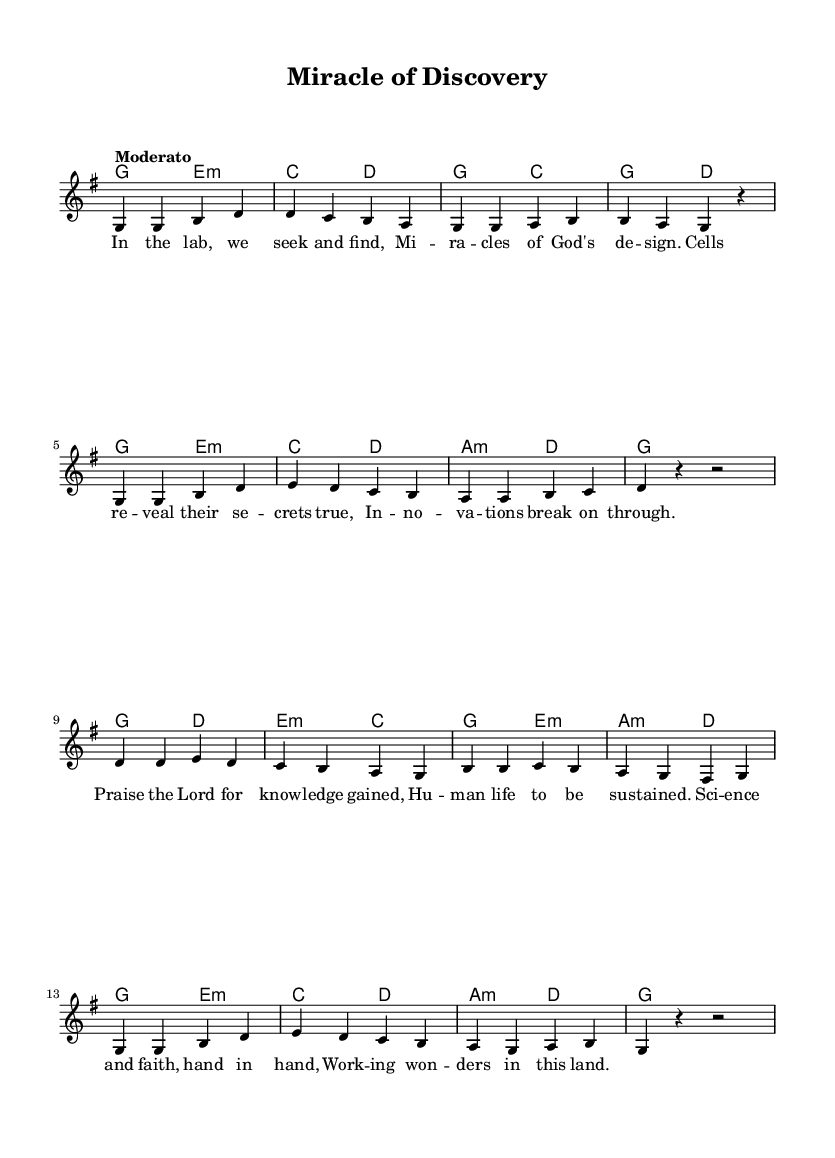What is the key signature of this music? The key signature is indicated at the beginning of the sheet music and shows one sharp (F#), which corresponds to the key of G major.
Answer: G major What is the time signature of this music? The time signature is located at the beginning of the score and shows a 4 over 4, indicating four beats in a measure.
Answer: 4/4 What is the tempo marking for this piece? The tempo marking appears near the beginning of the music and denotes "Moderato," indicating a moderate pace for the performance.
Answer: Moderato How many measures are there in the melody section? By counting the number of vertical lines (bar lines) in the melody, we can determine that there are a total of 16 measures present in the melody.
Answer: 16 What is the first lyric of the song? The lyrics start at the first note of the melody, which is "In the lab," indicating the opening phrase of the song.
Answer: In the lab What type of harmony is used in this piece? The chord symbols located above the staff indicate that basic triads and seventh chords are utilized, which is typical for Gospel music.
Answer: Triads What is the last lyric of the song? The last lyric corresponds to the end of the melody, clearly stated as "wonders in this land," marking the conclusion of the text.
Answer: wonders in this land 